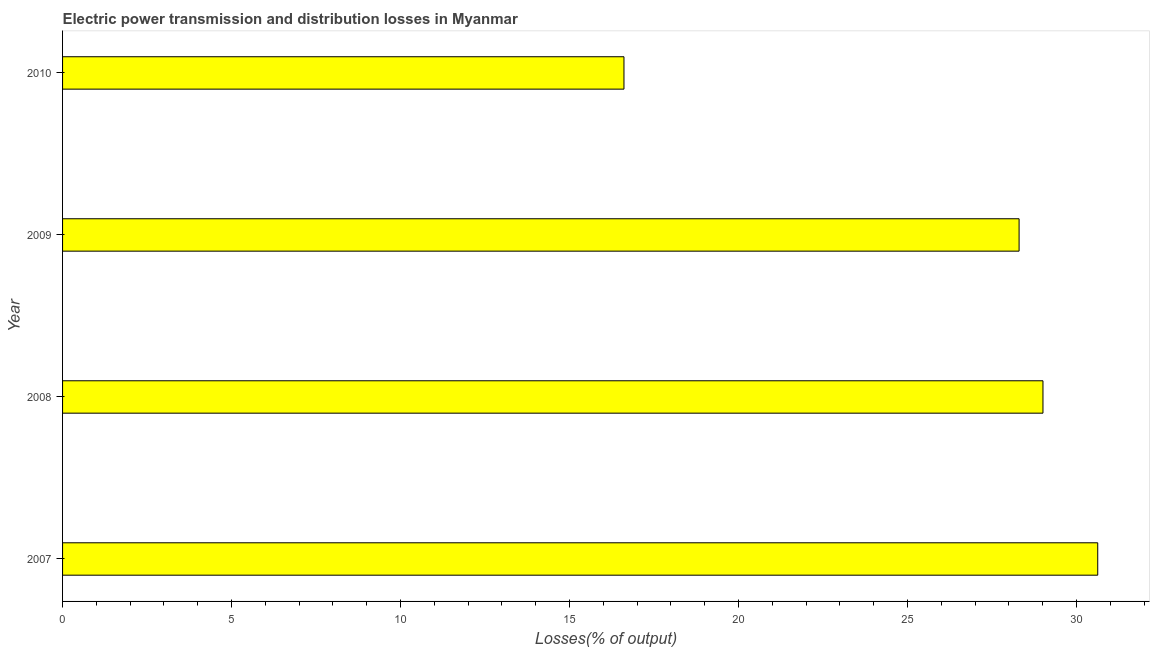Does the graph contain any zero values?
Offer a very short reply. No. Does the graph contain grids?
Ensure brevity in your answer.  No. What is the title of the graph?
Ensure brevity in your answer.  Electric power transmission and distribution losses in Myanmar. What is the label or title of the X-axis?
Offer a very short reply. Losses(% of output). What is the label or title of the Y-axis?
Give a very brief answer. Year. What is the electric power transmission and distribution losses in 2009?
Ensure brevity in your answer.  28.3. Across all years, what is the maximum electric power transmission and distribution losses?
Offer a terse response. 30.63. Across all years, what is the minimum electric power transmission and distribution losses?
Make the answer very short. 16.61. What is the sum of the electric power transmission and distribution losses?
Your response must be concise. 104.55. What is the difference between the electric power transmission and distribution losses in 2008 and 2009?
Your response must be concise. 0.71. What is the average electric power transmission and distribution losses per year?
Your answer should be compact. 26.14. What is the median electric power transmission and distribution losses?
Offer a very short reply. 28.66. In how many years, is the electric power transmission and distribution losses greater than 6 %?
Offer a very short reply. 4. Do a majority of the years between 2008 and 2009 (inclusive) have electric power transmission and distribution losses greater than 27 %?
Offer a very short reply. Yes. What is the ratio of the electric power transmission and distribution losses in 2007 to that in 2010?
Ensure brevity in your answer.  1.84. Is the electric power transmission and distribution losses in 2008 less than that in 2010?
Provide a short and direct response. No. What is the difference between the highest and the second highest electric power transmission and distribution losses?
Keep it short and to the point. 1.62. Is the sum of the electric power transmission and distribution losses in 2007 and 2010 greater than the maximum electric power transmission and distribution losses across all years?
Keep it short and to the point. Yes. What is the difference between the highest and the lowest electric power transmission and distribution losses?
Give a very brief answer. 14.02. In how many years, is the electric power transmission and distribution losses greater than the average electric power transmission and distribution losses taken over all years?
Keep it short and to the point. 3. How many bars are there?
Your answer should be compact. 4. How many years are there in the graph?
Ensure brevity in your answer.  4. What is the Losses(% of output) in 2007?
Your response must be concise. 30.63. What is the Losses(% of output) in 2008?
Provide a succinct answer. 29.01. What is the Losses(% of output) in 2009?
Your answer should be compact. 28.3. What is the Losses(% of output) of 2010?
Give a very brief answer. 16.61. What is the difference between the Losses(% of output) in 2007 and 2008?
Keep it short and to the point. 1.62. What is the difference between the Losses(% of output) in 2007 and 2009?
Ensure brevity in your answer.  2.33. What is the difference between the Losses(% of output) in 2007 and 2010?
Give a very brief answer. 14.02. What is the difference between the Losses(% of output) in 2008 and 2009?
Make the answer very short. 0.71. What is the difference between the Losses(% of output) in 2008 and 2010?
Your answer should be very brief. 12.4. What is the difference between the Losses(% of output) in 2009 and 2010?
Offer a terse response. 11.69. What is the ratio of the Losses(% of output) in 2007 to that in 2008?
Keep it short and to the point. 1.06. What is the ratio of the Losses(% of output) in 2007 to that in 2009?
Give a very brief answer. 1.08. What is the ratio of the Losses(% of output) in 2007 to that in 2010?
Keep it short and to the point. 1.84. What is the ratio of the Losses(% of output) in 2008 to that in 2010?
Give a very brief answer. 1.75. What is the ratio of the Losses(% of output) in 2009 to that in 2010?
Offer a very short reply. 1.7. 